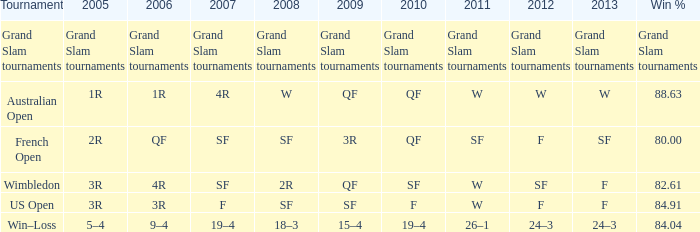What in 2013 possesses a 2009 of 3r? SF. 